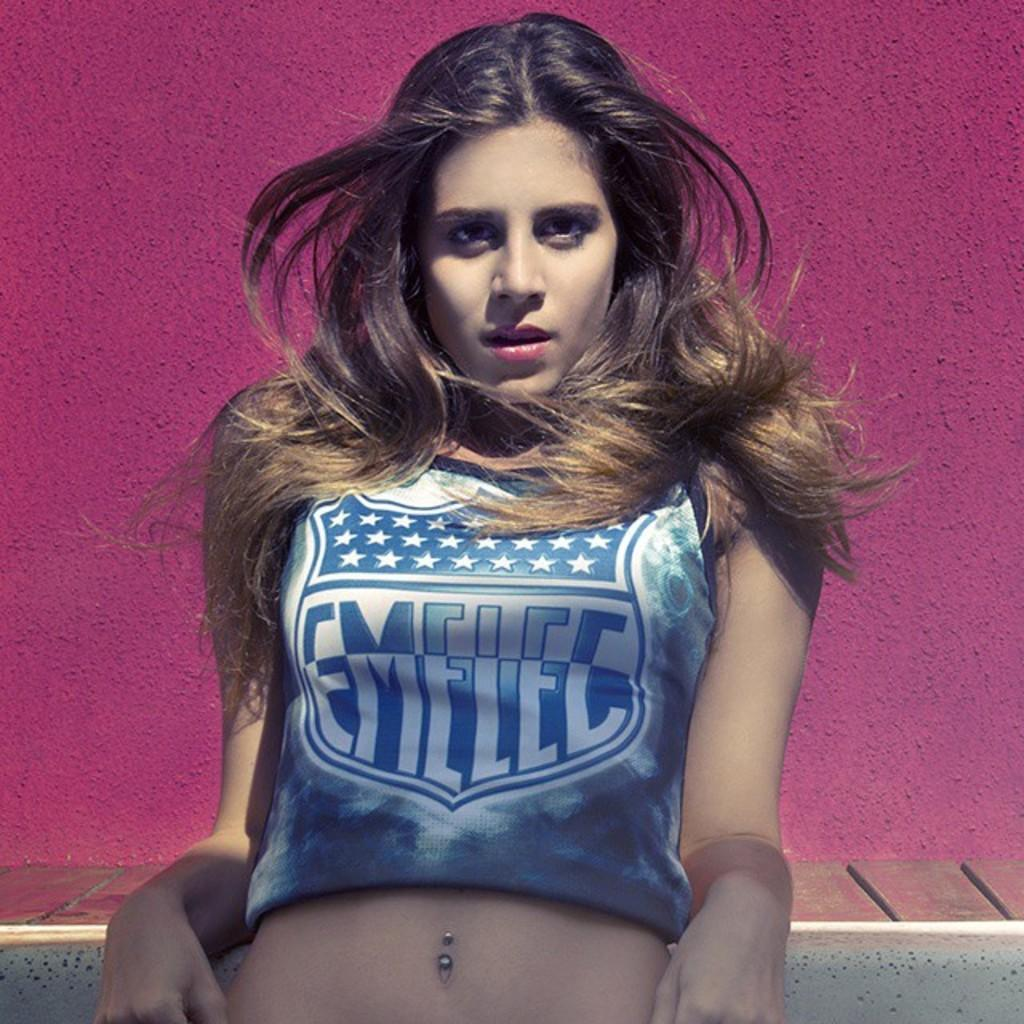<image>
Present a compact description of the photo's key features. Leaning back on her elbows, is a young woman wearing a blue and white shirt that has an interstate sign on the front saying EMELEC. 